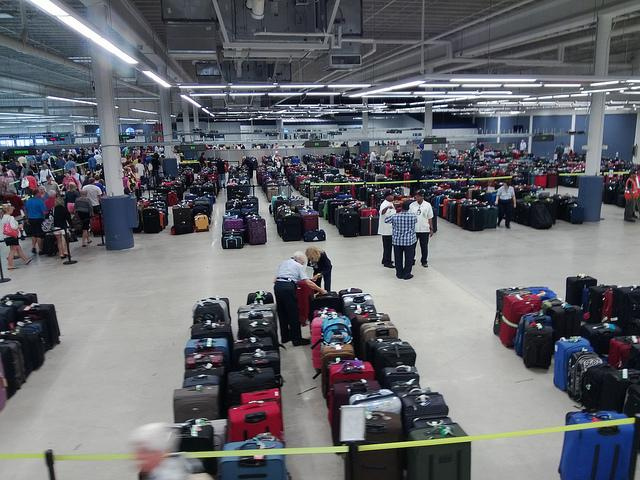What color is the tape fence around the luggage area where there is a number of luggage bags? yellow 